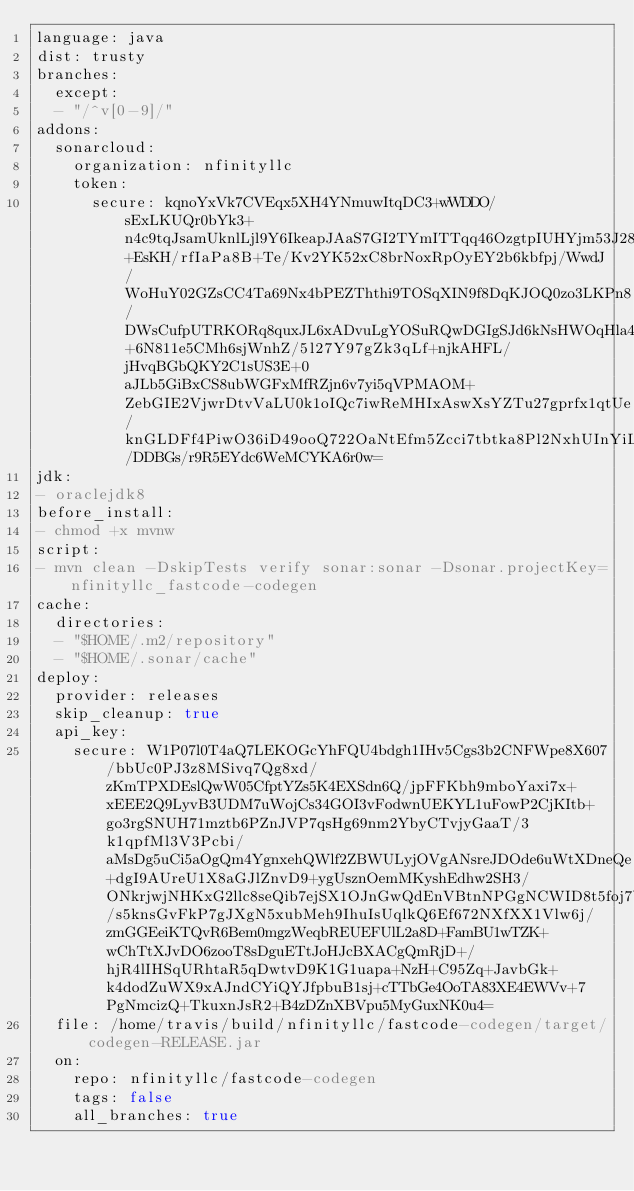<code> <loc_0><loc_0><loc_500><loc_500><_YAML_>language: java
dist: trusty
branches:
  except:
  - "/^v[0-9]/"
addons:
  sonarcloud:
    organization: nfinityllc
    token:
      secure: kqnoYxVk7CVEqx5XH4YNmuwItqDC3+wWDDO/sExLKUQr0bYk3+n4c9tqJsamUknlLjl9Y6IkeapJAaS7GI2TYmITTqq46OzgtpIUHYjm53J288XOjHKvWcrIjDlxHHm0e9EURci6WNT3tGiqRPOHw1iwusR6Rc1PilATcnQlGLDXKrsj2OlOPorc3SvtEEKcyWM1nU4MgR0EyRH0hSpllL2mRLb67uTNdA3MHwPUuD7jX1UYjvVXAllUHnJK2njJADgN+EsKH/rfIaPa8B+Te/Kv2YK52xC8brNoxRpOyEY2b6kbfpj/WwdJ/WoHuY02GZsCC4Ta69Nx4bPEZThthi9TOSqXIN9f8DqKJOQ0zo3LKPn8/DWsCufpUTRKORq8quxJL6xADvuLgYOSuRQwDGIgSJd6kNsHWOqHla4tBCRFohz0SJEs542+6N811e5CMh6sjWnhZ/5l27Y97gZk3qLf+njkAHFL/jHvqBGbQKY2C1sUS3E+0aJLb5GiBxCS8ubWGFxMfRZjn6v7yi5qVPMAOM+ZebGIE2VjwrDtvVaLU0k1oIQc7iwReMHIxAswXsYZTu27gprfx1qtUe/knGLDFf4PiwO36iD49ooQ722OaNtEfm5Zcci7tbtka8Pl2NxhUInYiLlbgSJt/DDBGs/r9R5EYdc6WeMCYKA6r0w=
jdk:
- oraclejdk8
before_install:
- chmod +x mvnw
script:
- mvn clean -DskipTests verify sonar:sonar -Dsonar.projectKey=nfinityllc_fastcode-codegen
cache:
  directories:
  - "$HOME/.m2/repository"
  - "$HOME/.sonar/cache"
deploy:
  provider: releases
  skip_cleanup: true
  api_key:
    secure: W1P07l0T4aQ7LEKOGcYhFQU4bdgh1IHv5Cgs3b2CNFWpe8X607/bbUc0PJ3z8MSivq7Qg8xd/zKmTPXDEslQwW05CfptYZs5K4EXSdn6Q/jpFFKbh9mboYaxi7x+xEEE2Q9LyvB3UDM7uWojCs34GOI3vFodwnUEKYL1uFowP2CjKItb+go3rgSNUH71mztb6PZnJVP7qsHg69nm2YbyCTvjyGaaT/3k1qpfMl3V3Pcbi/aMsDg5uCi5aOgQm4YgnxehQWlf2ZBWULyjOVgANsreJDOde6uWtXDneQe+dgI9AUreU1X8aGJlZnvD9+ygUsznOemMKyshEdhw2SH3/ONkrjwjNHKxG2llc8seQib7ejSX1OJnGwQdEnVBtnNPGgNCWID8t5foj7b0/s5knsGvFkP7gJXgN5xubMeh9IhuIsUqlkQ6Ef672NXfXX1Vlw6j/zmGGEeiKTQvR6Bem0mgzWeqbREUEFUlL2a8D+FamBU1wTZK+wChTtXJvDO6zooT8sDguETtJoHJcBXACgQmRjD+/hjR4lIHSqURhtaR5qDwtvD9K1G1uapa+NzH+C95Zq+JavbGk+k4dodZuWX9xAJndCYiQYJfpbuB1sj+cTTbGe4OoTA83XE4EWVv+7PgNmcizQ+TkuxnJsR2+B4zDZnXBVpu5MyGuxNK0u4=
  file: /home/travis/build/nfinityllc/fastcode-codegen/target/codegen-RELEASE.jar
  on:
    repo: nfinityllc/fastcode-codegen
    tags: false
    all_branches: true</code> 